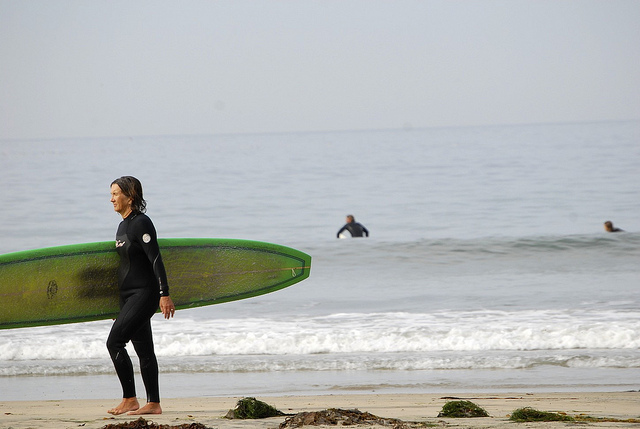Are there any other objects or landmarks in the image other than the people and their surfboards? Other than the people and their surfboards, the image shows some seaweed scattered along the shore. In the background, there is the vast and expansive ocean, but there are no distinct landmarks, buildings, or other objects present in the scene. 